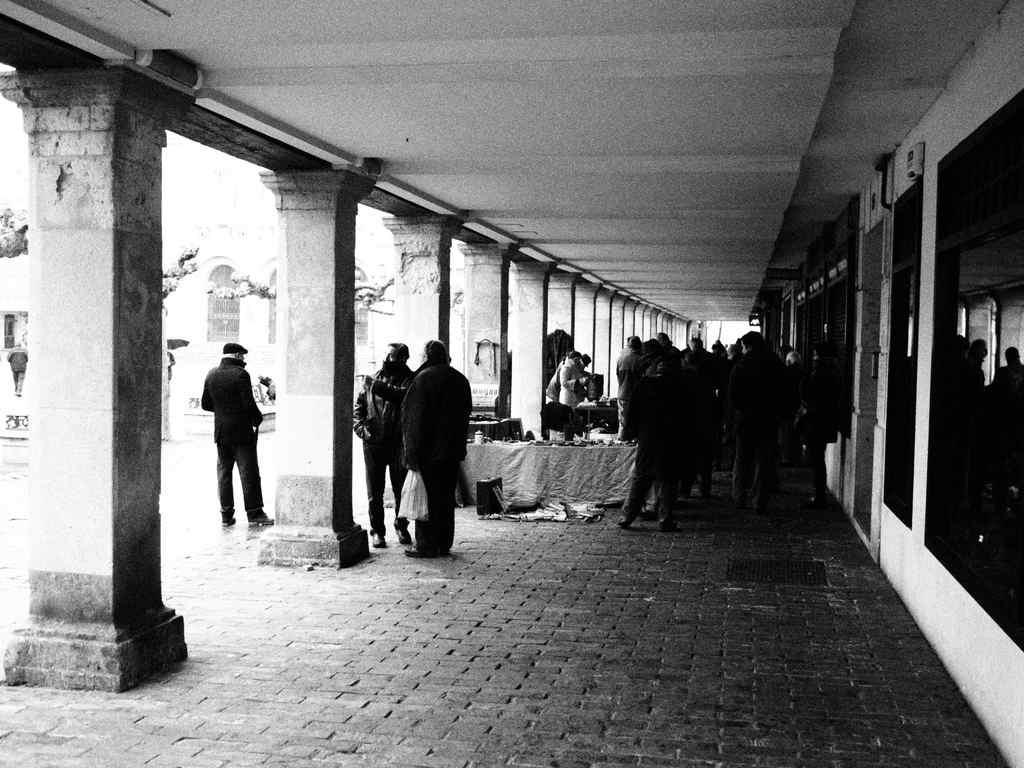Could you give a brief overview of what you see in this image? In this picture there are people and we can see pillars and objects on tables. We can see wall, windows and there are few objects. In the background of the image it is not clear. 